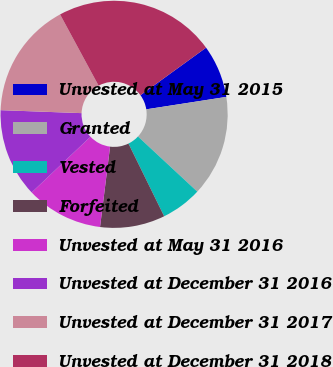Convert chart. <chart><loc_0><loc_0><loc_500><loc_500><pie_chart><fcel>Unvested at May 31 2015<fcel>Granted<fcel>Vested<fcel>Forfeited<fcel>Unvested at May 31 2016<fcel>Unvested at December 31 2016<fcel>Unvested at December 31 2017<fcel>Unvested at December 31 2018<nl><fcel>7.53%<fcel>14.37%<fcel>5.82%<fcel>9.24%<fcel>10.95%<fcel>12.66%<fcel>16.53%<fcel>22.91%<nl></chart> 